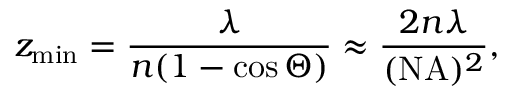<formula> <loc_0><loc_0><loc_500><loc_500>z _ { \min } = \frac { \lambda } { n ( 1 - \cos \Theta ) } \approx \frac { 2 n \lambda } { ( N A ) ^ { 2 } } ,</formula> 